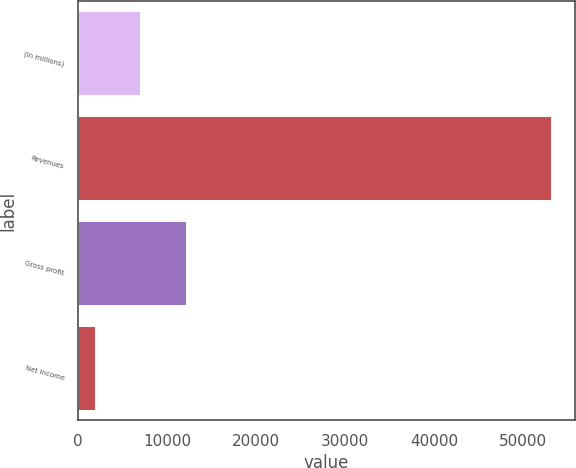<chart> <loc_0><loc_0><loc_500><loc_500><bar_chart><fcel>(In millions)<fcel>Revenues<fcel>Gross profit<fcel>Net income<nl><fcel>7007.2<fcel>53143<fcel>12133.4<fcel>1881<nl></chart> 